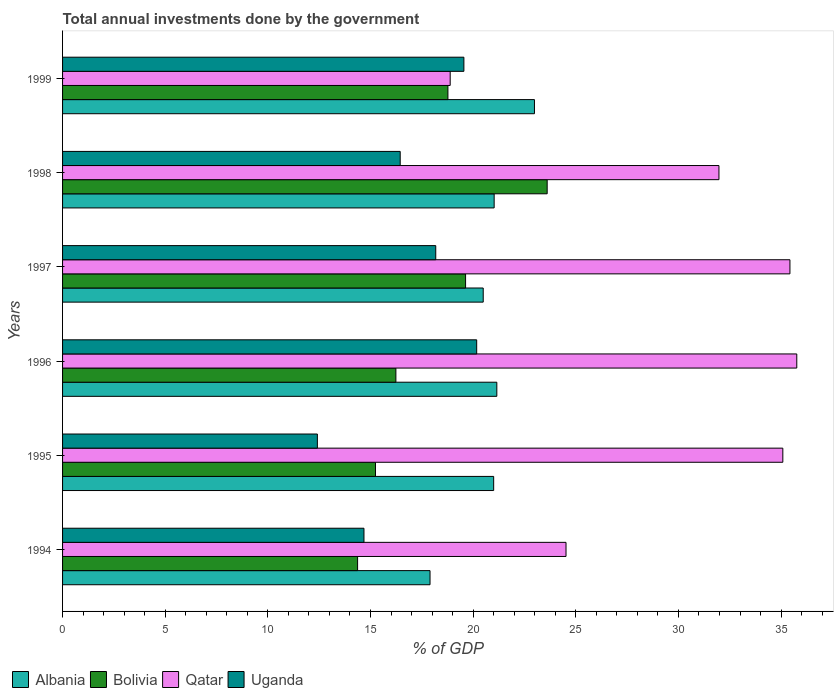How many groups of bars are there?
Offer a terse response. 6. How many bars are there on the 1st tick from the top?
Provide a short and direct response. 4. How many bars are there on the 3rd tick from the bottom?
Offer a terse response. 4. What is the total annual investments done by the government in Qatar in 1999?
Your answer should be compact. 18.88. Across all years, what is the maximum total annual investments done by the government in Bolivia?
Provide a succinct answer. 23.61. Across all years, what is the minimum total annual investments done by the government in Qatar?
Your answer should be compact. 18.88. In which year was the total annual investments done by the government in Albania minimum?
Your response must be concise. 1994. What is the total total annual investments done by the government in Albania in the graph?
Provide a short and direct response. 124.56. What is the difference between the total annual investments done by the government in Bolivia in 1997 and that in 1999?
Offer a terse response. 0.86. What is the difference between the total annual investments done by the government in Albania in 1994 and the total annual investments done by the government in Bolivia in 1996?
Offer a very short reply. 1.66. What is the average total annual investments done by the government in Qatar per year?
Provide a succinct answer. 30.28. In the year 1995, what is the difference between the total annual investments done by the government in Bolivia and total annual investments done by the government in Uganda?
Ensure brevity in your answer.  2.83. What is the ratio of the total annual investments done by the government in Bolivia in 1994 to that in 1995?
Your response must be concise. 0.94. Is the difference between the total annual investments done by the government in Bolivia in 1994 and 1998 greater than the difference between the total annual investments done by the government in Uganda in 1994 and 1998?
Offer a very short reply. No. What is the difference between the highest and the second highest total annual investments done by the government in Bolivia?
Give a very brief answer. 3.97. What is the difference between the highest and the lowest total annual investments done by the government in Bolivia?
Ensure brevity in your answer.  9.24. Is the sum of the total annual investments done by the government in Qatar in 1995 and 1997 greater than the maximum total annual investments done by the government in Albania across all years?
Provide a succinct answer. Yes. What does the 2nd bar from the top in 1998 represents?
Your response must be concise. Qatar. What does the 3rd bar from the bottom in 1998 represents?
Offer a terse response. Qatar. How many bars are there?
Provide a succinct answer. 24. What is the difference between two consecutive major ticks on the X-axis?
Offer a terse response. 5. Does the graph contain any zero values?
Keep it short and to the point. No. Does the graph contain grids?
Make the answer very short. No. How are the legend labels stacked?
Keep it short and to the point. Horizontal. What is the title of the graph?
Ensure brevity in your answer.  Total annual investments done by the government. Does "Madagascar" appear as one of the legend labels in the graph?
Offer a terse response. No. What is the label or title of the X-axis?
Give a very brief answer. % of GDP. What is the % of GDP in Albania in 1994?
Ensure brevity in your answer.  17.9. What is the % of GDP in Bolivia in 1994?
Offer a terse response. 14.37. What is the % of GDP in Qatar in 1994?
Offer a very short reply. 24.52. What is the % of GDP of Uganda in 1994?
Provide a short and direct response. 14.68. What is the % of GDP in Albania in 1995?
Offer a very short reply. 21. What is the % of GDP in Bolivia in 1995?
Make the answer very short. 15.24. What is the % of GDP of Qatar in 1995?
Your response must be concise. 35.09. What is the % of GDP of Uganda in 1995?
Offer a very short reply. 12.41. What is the % of GDP of Albania in 1996?
Offer a very short reply. 21.15. What is the % of GDP in Bolivia in 1996?
Provide a succinct answer. 16.24. What is the % of GDP of Qatar in 1996?
Provide a succinct answer. 35.77. What is the % of GDP in Uganda in 1996?
Keep it short and to the point. 20.17. What is the % of GDP in Albania in 1997?
Keep it short and to the point. 20.49. What is the % of GDP in Bolivia in 1997?
Offer a very short reply. 19.63. What is the % of GDP of Qatar in 1997?
Your answer should be very brief. 35.43. What is the % of GDP in Uganda in 1997?
Keep it short and to the point. 18.18. What is the % of GDP in Albania in 1998?
Your answer should be very brief. 21.02. What is the % of GDP of Bolivia in 1998?
Your answer should be very brief. 23.61. What is the % of GDP of Qatar in 1998?
Your answer should be compact. 31.97. What is the % of GDP in Uganda in 1998?
Keep it short and to the point. 16.45. What is the % of GDP in Albania in 1999?
Offer a terse response. 22.99. What is the % of GDP of Bolivia in 1999?
Keep it short and to the point. 18.77. What is the % of GDP in Qatar in 1999?
Your response must be concise. 18.88. What is the % of GDP in Uganda in 1999?
Ensure brevity in your answer.  19.55. Across all years, what is the maximum % of GDP in Albania?
Ensure brevity in your answer.  22.99. Across all years, what is the maximum % of GDP of Bolivia?
Make the answer very short. 23.61. Across all years, what is the maximum % of GDP in Qatar?
Give a very brief answer. 35.77. Across all years, what is the maximum % of GDP of Uganda?
Make the answer very short. 20.17. Across all years, what is the minimum % of GDP of Albania?
Give a very brief answer. 17.9. Across all years, what is the minimum % of GDP of Bolivia?
Ensure brevity in your answer.  14.37. Across all years, what is the minimum % of GDP of Qatar?
Provide a short and direct response. 18.88. Across all years, what is the minimum % of GDP in Uganda?
Make the answer very short. 12.41. What is the total % of GDP of Albania in the graph?
Keep it short and to the point. 124.56. What is the total % of GDP in Bolivia in the graph?
Offer a very short reply. 107.86. What is the total % of GDP of Qatar in the graph?
Keep it short and to the point. 181.66. What is the total % of GDP in Uganda in the graph?
Provide a short and direct response. 101.44. What is the difference between the % of GDP of Albania in 1994 and that in 1995?
Give a very brief answer. -3.1. What is the difference between the % of GDP in Bolivia in 1994 and that in 1995?
Your answer should be very brief. -0.87. What is the difference between the % of GDP of Qatar in 1994 and that in 1995?
Your answer should be compact. -10.56. What is the difference between the % of GDP in Uganda in 1994 and that in 1995?
Provide a succinct answer. 2.27. What is the difference between the % of GDP in Albania in 1994 and that in 1996?
Offer a terse response. -3.25. What is the difference between the % of GDP in Bolivia in 1994 and that in 1996?
Give a very brief answer. -1.87. What is the difference between the % of GDP in Qatar in 1994 and that in 1996?
Provide a short and direct response. -11.24. What is the difference between the % of GDP of Uganda in 1994 and that in 1996?
Offer a terse response. -5.49. What is the difference between the % of GDP in Albania in 1994 and that in 1997?
Offer a very short reply. -2.59. What is the difference between the % of GDP in Bolivia in 1994 and that in 1997?
Offer a very short reply. -5.26. What is the difference between the % of GDP in Qatar in 1994 and that in 1997?
Offer a very short reply. -10.91. What is the difference between the % of GDP in Uganda in 1994 and that in 1997?
Give a very brief answer. -3.5. What is the difference between the % of GDP in Albania in 1994 and that in 1998?
Offer a terse response. -3.12. What is the difference between the % of GDP of Bolivia in 1994 and that in 1998?
Give a very brief answer. -9.24. What is the difference between the % of GDP of Qatar in 1994 and that in 1998?
Make the answer very short. -7.45. What is the difference between the % of GDP in Uganda in 1994 and that in 1998?
Offer a very short reply. -1.77. What is the difference between the % of GDP of Albania in 1994 and that in 1999?
Keep it short and to the point. -5.09. What is the difference between the % of GDP in Bolivia in 1994 and that in 1999?
Your response must be concise. -4.4. What is the difference between the % of GDP in Qatar in 1994 and that in 1999?
Ensure brevity in your answer.  5.64. What is the difference between the % of GDP of Uganda in 1994 and that in 1999?
Keep it short and to the point. -4.87. What is the difference between the % of GDP in Albania in 1995 and that in 1996?
Give a very brief answer. -0.15. What is the difference between the % of GDP in Bolivia in 1995 and that in 1996?
Your response must be concise. -0.99. What is the difference between the % of GDP in Qatar in 1995 and that in 1996?
Your response must be concise. -0.68. What is the difference between the % of GDP in Uganda in 1995 and that in 1996?
Your response must be concise. -7.76. What is the difference between the % of GDP in Albania in 1995 and that in 1997?
Ensure brevity in your answer.  0.51. What is the difference between the % of GDP of Bolivia in 1995 and that in 1997?
Your response must be concise. -4.39. What is the difference between the % of GDP of Qatar in 1995 and that in 1997?
Your answer should be very brief. -0.35. What is the difference between the % of GDP in Uganda in 1995 and that in 1997?
Provide a succinct answer. -5.77. What is the difference between the % of GDP of Albania in 1995 and that in 1998?
Ensure brevity in your answer.  -0.02. What is the difference between the % of GDP of Bolivia in 1995 and that in 1998?
Make the answer very short. -8.36. What is the difference between the % of GDP in Qatar in 1995 and that in 1998?
Offer a very short reply. 3.11. What is the difference between the % of GDP in Uganda in 1995 and that in 1998?
Provide a short and direct response. -4.04. What is the difference between the % of GDP of Albania in 1995 and that in 1999?
Give a very brief answer. -1.99. What is the difference between the % of GDP of Bolivia in 1995 and that in 1999?
Your answer should be very brief. -3.53. What is the difference between the % of GDP in Qatar in 1995 and that in 1999?
Make the answer very short. 16.2. What is the difference between the % of GDP in Uganda in 1995 and that in 1999?
Provide a succinct answer. -7.14. What is the difference between the % of GDP in Albania in 1996 and that in 1997?
Your answer should be compact. 0.66. What is the difference between the % of GDP in Bolivia in 1996 and that in 1997?
Give a very brief answer. -3.39. What is the difference between the % of GDP in Qatar in 1996 and that in 1997?
Provide a short and direct response. 0.33. What is the difference between the % of GDP of Uganda in 1996 and that in 1997?
Provide a succinct answer. 1.99. What is the difference between the % of GDP in Albania in 1996 and that in 1998?
Your answer should be very brief. 0.13. What is the difference between the % of GDP of Bolivia in 1996 and that in 1998?
Ensure brevity in your answer.  -7.37. What is the difference between the % of GDP of Qatar in 1996 and that in 1998?
Offer a very short reply. 3.79. What is the difference between the % of GDP of Uganda in 1996 and that in 1998?
Provide a succinct answer. 3.73. What is the difference between the % of GDP of Albania in 1996 and that in 1999?
Offer a very short reply. -1.83. What is the difference between the % of GDP of Bolivia in 1996 and that in 1999?
Make the answer very short. -2.53. What is the difference between the % of GDP in Qatar in 1996 and that in 1999?
Provide a succinct answer. 16.88. What is the difference between the % of GDP of Uganda in 1996 and that in 1999?
Offer a very short reply. 0.62. What is the difference between the % of GDP of Albania in 1997 and that in 1998?
Make the answer very short. -0.53. What is the difference between the % of GDP in Bolivia in 1997 and that in 1998?
Keep it short and to the point. -3.97. What is the difference between the % of GDP in Qatar in 1997 and that in 1998?
Make the answer very short. 3.46. What is the difference between the % of GDP in Uganda in 1997 and that in 1998?
Your answer should be compact. 1.73. What is the difference between the % of GDP of Albania in 1997 and that in 1999?
Give a very brief answer. -2.5. What is the difference between the % of GDP in Bolivia in 1997 and that in 1999?
Provide a succinct answer. 0.86. What is the difference between the % of GDP in Qatar in 1997 and that in 1999?
Your answer should be very brief. 16.55. What is the difference between the % of GDP of Uganda in 1997 and that in 1999?
Provide a succinct answer. -1.37. What is the difference between the % of GDP in Albania in 1998 and that in 1999?
Offer a terse response. -1.96. What is the difference between the % of GDP in Bolivia in 1998 and that in 1999?
Offer a very short reply. 4.83. What is the difference between the % of GDP in Qatar in 1998 and that in 1999?
Keep it short and to the point. 13.09. What is the difference between the % of GDP in Uganda in 1998 and that in 1999?
Offer a terse response. -3.1. What is the difference between the % of GDP in Albania in 1994 and the % of GDP in Bolivia in 1995?
Provide a succinct answer. 2.66. What is the difference between the % of GDP of Albania in 1994 and the % of GDP of Qatar in 1995?
Your answer should be very brief. -17.19. What is the difference between the % of GDP in Albania in 1994 and the % of GDP in Uganda in 1995?
Keep it short and to the point. 5.49. What is the difference between the % of GDP of Bolivia in 1994 and the % of GDP of Qatar in 1995?
Ensure brevity in your answer.  -20.71. What is the difference between the % of GDP in Bolivia in 1994 and the % of GDP in Uganda in 1995?
Provide a succinct answer. 1.96. What is the difference between the % of GDP in Qatar in 1994 and the % of GDP in Uganda in 1995?
Your response must be concise. 12.11. What is the difference between the % of GDP of Albania in 1994 and the % of GDP of Bolivia in 1996?
Ensure brevity in your answer.  1.66. What is the difference between the % of GDP of Albania in 1994 and the % of GDP of Qatar in 1996?
Offer a terse response. -17.87. What is the difference between the % of GDP of Albania in 1994 and the % of GDP of Uganda in 1996?
Offer a very short reply. -2.27. What is the difference between the % of GDP in Bolivia in 1994 and the % of GDP in Qatar in 1996?
Ensure brevity in your answer.  -21.39. What is the difference between the % of GDP in Bolivia in 1994 and the % of GDP in Uganda in 1996?
Ensure brevity in your answer.  -5.8. What is the difference between the % of GDP in Qatar in 1994 and the % of GDP in Uganda in 1996?
Your answer should be very brief. 4.35. What is the difference between the % of GDP of Albania in 1994 and the % of GDP of Bolivia in 1997?
Provide a succinct answer. -1.73. What is the difference between the % of GDP of Albania in 1994 and the % of GDP of Qatar in 1997?
Ensure brevity in your answer.  -17.53. What is the difference between the % of GDP of Albania in 1994 and the % of GDP of Uganda in 1997?
Offer a very short reply. -0.28. What is the difference between the % of GDP in Bolivia in 1994 and the % of GDP in Qatar in 1997?
Ensure brevity in your answer.  -21.06. What is the difference between the % of GDP of Bolivia in 1994 and the % of GDP of Uganda in 1997?
Offer a very short reply. -3.81. What is the difference between the % of GDP of Qatar in 1994 and the % of GDP of Uganda in 1997?
Ensure brevity in your answer.  6.35. What is the difference between the % of GDP of Albania in 1994 and the % of GDP of Bolivia in 1998?
Ensure brevity in your answer.  -5.71. What is the difference between the % of GDP of Albania in 1994 and the % of GDP of Qatar in 1998?
Keep it short and to the point. -14.07. What is the difference between the % of GDP in Albania in 1994 and the % of GDP in Uganda in 1998?
Your response must be concise. 1.45. What is the difference between the % of GDP in Bolivia in 1994 and the % of GDP in Qatar in 1998?
Give a very brief answer. -17.6. What is the difference between the % of GDP in Bolivia in 1994 and the % of GDP in Uganda in 1998?
Offer a very short reply. -2.08. What is the difference between the % of GDP of Qatar in 1994 and the % of GDP of Uganda in 1998?
Keep it short and to the point. 8.08. What is the difference between the % of GDP of Albania in 1994 and the % of GDP of Bolivia in 1999?
Offer a very short reply. -0.87. What is the difference between the % of GDP in Albania in 1994 and the % of GDP in Qatar in 1999?
Make the answer very short. -0.98. What is the difference between the % of GDP in Albania in 1994 and the % of GDP in Uganda in 1999?
Your answer should be very brief. -1.65. What is the difference between the % of GDP of Bolivia in 1994 and the % of GDP of Qatar in 1999?
Offer a terse response. -4.51. What is the difference between the % of GDP of Bolivia in 1994 and the % of GDP of Uganda in 1999?
Your answer should be very brief. -5.18. What is the difference between the % of GDP in Qatar in 1994 and the % of GDP in Uganda in 1999?
Your response must be concise. 4.97. What is the difference between the % of GDP of Albania in 1995 and the % of GDP of Bolivia in 1996?
Your answer should be compact. 4.76. What is the difference between the % of GDP in Albania in 1995 and the % of GDP in Qatar in 1996?
Keep it short and to the point. -14.77. What is the difference between the % of GDP in Albania in 1995 and the % of GDP in Uganda in 1996?
Keep it short and to the point. 0.83. What is the difference between the % of GDP of Bolivia in 1995 and the % of GDP of Qatar in 1996?
Your answer should be compact. -20.52. What is the difference between the % of GDP in Bolivia in 1995 and the % of GDP in Uganda in 1996?
Ensure brevity in your answer.  -4.93. What is the difference between the % of GDP in Qatar in 1995 and the % of GDP in Uganda in 1996?
Your answer should be compact. 14.91. What is the difference between the % of GDP of Albania in 1995 and the % of GDP of Bolivia in 1997?
Make the answer very short. 1.37. What is the difference between the % of GDP of Albania in 1995 and the % of GDP of Qatar in 1997?
Make the answer very short. -14.43. What is the difference between the % of GDP in Albania in 1995 and the % of GDP in Uganda in 1997?
Offer a terse response. 2.82. What is the difference between the % of GDP of Bolivia in 1995 and the % of GDP of Qatar in 1997?
Give a very brief answer. -20.19. What is the difference between the % of GDP in Bolivia in 1995 and the % of GDP in Uganda in 1997?
Make the answer very short. -2.93. What is the difference between the % of GDP of Qatar in 1995 and the % of GDP of Uganda in 1997?
Make the answer very short. 16.91. What is the difference between the % of GDP in Albania in 1995 and the % of GDP in Bolivia in 1998?
Offer a very short reply. -2.61. What is the difference between the % of GDP in Albania in 1995 and the % of GDP in Qatar in 1998?
Provide a short and direct response. -10.97. What is the difference between the % of GDP of Albania in 1995 and the % of GDP of Uganda in 1998?
Provide a succinct answer. 4.55. What is the difference between the % of GDP of Bolivia in 1995 and the % of GDP of Qatar in 1998?
Your response must be concise. -16.73. What is the difference between the % of GDP of Bolivia in 1995 and the % of GDP of Uganda in 1998?
Give a very brief answer. -1.2. What is the difference between the % of GDP of Qatar in 1995 and the % of GDP of Uganda in 1998?
Your response must be concise. 18.64. What is the difference between the % of GDP of Albania in 1995 and the % of GDP of Bolivia in 1999?
Provide a short and direct response. 2.23. What is the difference between the % of GDP of Albania in 1995 and the % of GDP of Qatar in 1999?
Your answer should be very brief. 2.12. What is the difference between the % of GDP in Albania in 1995 and the % of GDP in Uganda in 1999?
Your response must be concise. 1.45. What is the difference between the % of GDP of Bolivia in 1995 and the % of GDP of Qatar in 1999?
Make the answer very short. -3.64. What is the difference between the % of GDP in Bolivia in 1995 and the % of GDP in Uganda in 1999?
Offer a terse response. -4.31. What is the difference between the % of GDP in Qatar in 1995 and the % of GDP in Uganda in 1999?
Make the answer very short. 15.54. What is the difference between the % of GDP in Albania in 1996 and the % of GDP in Bolivia in 1997?
Keep it short and to the point. 1.52. What is the difference between the % of GDP of Albania in 1996 and the % of GDP of Qatar in 1997?
Your response must be concise. -14.28. What is the difference between the % of GDP of Albania in 1996 and the % of GDP of Uganda in 1997?
Keep it short and to the point. 2.98. What is the difference between the % of GDP of Bolivia in 1996 and the % of GDP of Qatar in 1997?
Ensure brevity in your answer.  -19.19. What is the difference between the % of GDP in Bolivia in 1996 and the % of GDP in Uganda in 1997?
Your response must be concise. -1.94. What is the difference between the % of GDP of Qatar in 1996 and the % of GDP of Uganda in 1997?
Keep it short and to the point. 17.59. What is the difference between the % of GDP in Albania in 1996 and the % of GDP in Bolivia in 1998?
Your response must be concise. -2.45. What is the difference between the % of GDP in Albania in 1996 and the % of GDP in Qatar in 1998?
Make the answer very short. -10.82. What is the difference between the % of GDP in Albania in 1996 and the % of GDP in Uganda in 1998?
Offer a terse response. 4.71. What is the difference between the % of GDP of Bolivia in 1996 and the % of GDP of Qatar in 1998?
Give a very brief answer. -15.74. What is the difference between the % of GDP of Bolivia in 1996 and the % of GDP of Uganda in 1998?
Your response must be concise. -0.21. What is the difference between the % of GDP in Qatar in 1996 and the % of GDP in Uganda in 1998?
Your answer should be very brief. 19.32. What is the difference between the % of GDP in Albania in 1996 and the % of GDP in Bolivia in 1999?
Provide a short and direct response. 2.38. What is the difference between the % of GDP of Albania in 1996 and the % of GDP of Qatar in 1999?
Your response must be concise. 2.27. What is the difference between the % of GDP of Albania in 1996 and the % of GDP of Uganda in 1999?
Your response must be concise. 1.61. What is the difference between the % of GDP in Bolivia in 1996 and the % of GDP in Qatar in 1999?
Offer a very short reply. -2.65. What is the difference between the % of GDP of Bolivia in 1996 and the % of GDP of Uganda in 1999?
Your answer should be very brief. -3.31. What is the difference between the % of GDP in Qatar in 1996 and the % of GDP in Uganda in 1999?
Make the answer very short. 16.22. What is the difference between the % of GDP of Albania in 1997 and the % of GDP of Bolivia in 1998?
Provide a succinct answer. -3.12. What is the difference between the % of GDP in Albania in 1997 and the % of GDP in Qatar in 1998?
Offer a very short reply. -11.48. What is the difference between the % of GDP of Albania in 1997 and the % of GDP of Uganda in 1998?
Give a very brief answer. 4.04. What is the difference between the % of GDP of Bolivia in 1997 and the % of GDP of Qatar in 1998?
Provide a succinct answer. -12.34. What is the difference between the % of GDP in Bolivia in 1997 and the % of GDP in Uganda in 1998?
Give a very brief answer. 3.18. What is the difference between the % of GDP of Qatar in 1997 and the % of GDP of Uganda in 1998?
Give a very brief answer. 18.98. What is the difference between the % of GDP of Albania in 1997 and the % of GDP of Bolivia in 1999?
Your response must be concise. 1.72. What is the difference between the % of GDP of Albania in 1997 and the % of GDP of Qatar in 1999?
Your response must be concise. 1.61. What is the difference between the % of GDP of Albania in 1997 and the % of GDP of Uganda in 1999?
Your answer should be compact. 0.94. What is the difference between the % of GDP in Bolivia in 1997 and the % of GDP in Qatar in 1999?
Make the answer very short. 0.75. What is the difference between the % of GDP of Bolivia in 1997 and the % of GDP of Uganda in 1999?
Offer a terse response. 0.08. What is the difference between the % of GDP of Qatar in 1997 and the % of GDP of Uganda in 1999?
Offer a very short reply. 15.88. What is the difference between the % of GDP of Albania in 1998 and the % of GDP of Bolivia in 1999?
Provide a succinct answer. 2.25. What is the difference between the % of GDP of Albania in 1998 and the % of GDP of Qatar in 1999?
Give a very brief answer. 2.14. What is the difference between the % of GDP in Albania in 1998 and the % of GDP in Uganda in 1999?
Your answer should be very brief. 1.47. What is the difference between the % of GDP of Bolivia in 1998 and the % of GDP of Qatar in 1999?
Give a very brief answer. 4.72. What is the difference between the % of GDP of Bolivia in 1998 and the % of GDP of Uganda in 1999?
Provide a succinct answer. 4.06. What is the difference between the % of GDP of Qatar in 1998 and the % of GDP of Uganda in 1999?
Your answer should be compact. 12.43. What is the average % of GDP of Albania per year?
Offer a very short reply. 20.76. What is the average % of GDP of Bolivia per year?
Provide a short and direct response. 17.98. What is the average % of GDP of Qatar per year?
Ensure brevity in your answer.  30.28. What is the average % of GDP of Uganda per year?
Offer a terse response. 16.91. In the year 1994, what is the difference between the % of GDP of Albania and % of GDP of Bolivia?
Your answer should be compact. 3.53. In the year 1994, what is the difference between the % of GDP in Albania and % of GDP in Qatar?
Ensure brevity in your answer.  -6.62. In the year 1994, what is the difference between the % of GDP in Albania and % of GDP in Uganda?
Keep it short and to the point. 3.22. In the year 1994, what is the difference between the % of GDP in Bolivia and % of GDP in Qatar?
Provide a short and direct response. -10.15. In the year 1994, what is the difference between the % of GDP of Bolivia and % of GDP of Uganda?
Give a very brief answer. -0.31. In the year 1994, what is the difference between the % of GDP in Qatar and % of GDP in Uganda?
Your answer should be very brief. 9.84. In the year 1995, what is the difference between the % of GDP in Albania and % of GDP in Bolivia?
Give a very brief answer. 5.76. In the year 1995, what is the difference between the % of GDP of Albania and % of GDP of Qatar?
Your answer should be very brief. -14.09. In the year 1995, what is the difference between the % of GDP in Albania and % of GDP in Uganda?
Provide a short and direct response. 8.59. In the year 1995, what is the difference between the % of GDP of Bolivia and % of GDP of Qatar?
Provide a short and direct response. -19.84. In the year 1995, what is the difference between the % of GDP of Bolivia and % of GDP of Uganda?
Make the answer very short. 2.83. In the year 1995, what is the difference between the % of GDP in Qatar and % of GDP in Uganda?
Offer a terse response. 22.67. In the year 1996, what is the difference between the % of GDP of Albania and % of GDP of Bolivia?
Provide a succinct answer. 4.92. In the year 1996, what is the difference between the % of GDP of Albania and % of GDP of Qatar?
Give a very brief answer. -14.61. In the year 1996, what is the difference between the % of GDP in Albania and % of GDP in Uganda?
Your answer should be compact. 0.98. In the year 1996, what is the difference between the % of GDP in Bolivia and % of GDP in Qatar?
Ensure brevity in your answer.  -19.53. In the year 1996, what is the difference between the % of GDP of Bolivia and % of GDP of Uganda?
Your answer should be compact. -3.94. In the year 1996, what is the difference between the % of GDP in Qatar and % of GDP in Uganda?
Keep it short and to the point. 15.59. In the year 1997, what is the difference between the % of GDP in Albania and % of GDP in Bolivia?
Give a very brief answer. 0.86. In the year 1997, what is the difference between the % of GDP of Albania and % of GDP of Qatar?
Provide a short and direct response. -14.94. In the year 1997, what is the difference between the % of GDP of Albania and % of GDP of Uganda?
Ensure brevity in your answer.  2.31. In the year 1997, what is the difference between the % of GDP of Bolivia and % of GDP of Qatar?
Your response must be concise. -15.8. In the year 1997, what is the difference between the % of GDP of Bolivia and % of GDP of Uganda?
Offer a terse response. 1.45. In the year 1997, what is the difference between the % of GDP of Qatar and % of GDP of Uganda?
Provide a short and direct response. 17.25. In the year 1998, what is the difference between the % of GDP in Albania and % of GDP in Bolivia?
Keep it short and to the point. -2.58. In the year 1998, what is the difference between the % of GDP in Albania and % of GDP in Qatar?
Keep it short and to the point. -10.95. In the year 1998, what is the difference between the % of GDP in Albania and % of GDP in Uganda?
Ensure brevity in your answer.  4.58. In the year 1998, what is the difference between the % of GDP in Bolivia and % of GDP in Qatar?
Make the answer very short. -8.37. In the year 1998, what is the difference between the % of GDP in Bolivia and % of GDP in Uganda?
Your answer should be very brief. 7.16. In the year 1998, what is the difference between the % of GDP in Qatar and % of GDP in Uganda?
Your answer should be compact. 15.53. In the year 1999, what is the difference between the % of GDP of Albania and % of GDP of Bolivia?
Give a very brief answer. 4.21. In the year 1999, what is the difference between the % of GDP in Albania and % of GDP in Qatar?
Offer a terse response. 4.1. In the year 1999, what is the difference between the % of GDP in Albania and % of GDP in Uganda?
Provide a short and direct response. 3.44. In the year 1999, what is the difference between the % of GDP in Bolivia and % of GDP in Qatar?
Your answer should be very brief. -0.11. In the year 1999, what is the difference between the % of GDP of Bolivia and % of GDP of Uganda?
Offer a very short reply. -0.78. In the year 1999, what is the difference between the % of GDP in Qatar and % of GDP in Uganda?
Provide a succinct answer. -0.67. What is the ratio of the % of GDP of Albania in 1994 to that in 1995?
Make the answer very short. 0.85. What is the ratio of the % of GDP of Bolivia in 1994 to that in 1995?
Make the answer very short. 0.94. What is the ratio of the % of GDP in Qatar in 1994 to that in 1995?
Make the answer very short. 0.7. What is the ratio of the % of GDP of Uganda in 1994 to that in 1995?
Offer a terse response. 1.18. What is the ratio of the % of GDP in Albania in 1994 to that in 1996?
Keep it short and to the point. 0.85. What is the ratio of the % of GDP in Bolivia in 1994 to that in 1996?
Your answer should be compact. 0.89. What is the ratio of the % of GDP in Qatar in 1994 to that in 1996?
Make the answer very short. 0.69. What is the ratio of the % of GDP of Uganda in 1994 to that in 1996?
Your answer should be compact. 0.73. What is the ratio of the % of GDP of Albania in 1994 to that in 1997?
Offer a very short reply. 0.87. What is the ratio of the % of GDP in Bolivia in 1994 to that in 1997?
Your answer should be very brief. 0.73. What is the ratio of the % of GDP of Qatar in 1994 to that in 1997?
Keep it short and to the point. 0.69. What is the ratio of the % of GDP of Uganda in 1994 to that in 1997?
Offer a terse response. 0.81. What is the ratio of the % of GDP of Albania in 1994 to that in 1998?
Your response must be concise. 0.85. What is the ratio of the % of GDP in Bolivia in 1994 to that in 1998?
Offer a very short reply. 0.61. What is the ratio of the % of GDP in Qatar in 1994 to that in 1998?
Offer a very short reply. 0.77. What is the ratio of the % of GDP in Uganda in 1994 to that in 1998?
Your answer should be compact. 0.89. What is the ratio of the % of GDP of Albania in 1994 to that in 1999?
Provide a succinct answer. 0.78. What is the ratio of the % of GDP in Bolivia in 1994 to that in 1999?
Provide a succinct answer. 0.77. What is the ratio of the % of GDP in Qatar in 1994 to that in 1999?
Provide a succinct answer. 1.3. What is the ratio of the % of GDP of Uganda in 1994 to that in 1999?
Offer a terse response. 0.75. What is the ratio of the % of GDP of Albania in 1995 to that in 1996?
Your answer should be compact. 0.99. What is the ratio of the % of GDP of Bolivia in 1995 to that in 1996?
Keep it short and to the point. 0.94. What is the ratio of the % of GDP of Qatar in 1995 to that in 1996?
Keep it short and to the point. 0.98. What is the ratio of the % of GDP of Uganda in 1995 to that in 1996?
Keep it short and to the point. 0.62. What is the ratio of the % of GDP of Albania in 1995 to that in 1997?
Your response must be concise. 1.02. What is the ratio of the % of GDP of Bolivia in 1995 to that in 1997?
Keep it short and to the point. 0.78. What is the ratio of the % of GDP of Qatar in 1995 to that in 1997?
Your response must be concise. 0.99. What is the ratio of the % of GDP of Uganda in 1995 to that in 1997?
Give a very brief answer. 0.68. What is the ratio of the % of GDP in Albania in 1995 to that in 1998?
Your answer should be very brief. 1. What is the ratio of the % of GDP in Bolivia in 1995 to that in 1998?
Provide a succinct answer. 0.65. What is the ratio of the % of GDP in Qatar in 1995 to that in 1998?
Your answer should be compact. 1.1. What is the ratio of the % of GDP of Uganda in 1995 to that in 1998?
Your response must be concise. 0.75. What is the ratio of the % of GDP in Albania in 1995 to that in 1999?
Provide a succinct answer. 0.91. What is the ratio of the % of GDP of Bolivia in 1995 to that in 1999?
Your answer should be very brief. 0.81. What is the ratio of the % of GDP of Qatar in 1995 to that in 1999?
Your answer should be compact. 1.86. What is the ratio of the % of GDP of Uganda in 1995 to that in 1999?
Your answer should be very brief. 0.63. What is the ratio of the % of GDP in Albania in 1996 to that in 1997?
Offer a terse response. 1.03. What is the ratio of the % of GDP of Bolivia in 1996 to that in 1997?
Give a very brief answer. 0.83. What is the ratio of the % of GDP of Qatar in 1996 to that in 1997?
Offer a terse response. 1.01. What is the ratio of the % of GDP of Uganda in 1996 to that in 1997?
Your response must be concise. 1.11. What is the ratio of the % of GDP in Bolivia in 1996 to that in 1998?
Ensure brevity in your answer.  0.69. What is the ratio of the % of GDP of Qatar in 1996 to that in 1998?
Ensure brevity in your answer.  1.12. What is the ratio of the % of GDP of Uganda in 1996 to that in 1998?
Offer a very short reply. 1.23. What is the ratio of the % of GDP of Albania in 1996 to that in 1999?
Ensure brevity in your answer.  0.92. What is the ratio of the % of GDP of Bolivia in 1996 to that in 1999?
Give a very brief answer. 0.86. What is the ratio of the % of GDP in Qatar in 1996 to that in 1999?
Offer a terse response. 1.89. What is the ratio of the % of GDP of Uganda in 1996 to that in 1999?
Provide a succinct answer. 1.03. What is the ratio of the % of GDP of Albania in 1997 to that in 1998?
Your answer should be compact. 0.97. What is the ratio of the % of GDP of Bolivia in 1997 to that in 1998?
Your response must be concise. 0.83. What is the ratio of the % of GDP in Qatar in 1997 to that in 1998?
Provide a succinct answer. 1.11. What is the ratio of the % of GDP in Uganda in 1997 to that in 1998?
Provide a succinct answer. 1.11. What is the ratio of the % of GDP in Albania in 1997 to that in 1999?
Your response must be concise. 0.89. What is the ratio of the % of GDP in Bolivia in 1997 to that in 1999?
Ensure brevity in your answer.  1.05. What is the ratio of the % of GDP in Qatar in 1997 to that in 1999?
Your answer should be very brief. 1.88. What is the ratio of the % of GDP in Uganda in 1997 to that in 1999?
Your answer should be very brief. 0.93. What is the ratio of the % of GDP of Albania in 1998 to that in 1999?
Provide a short and direct response. 0.91. What is the ratio of the % of GDP in Bolivia in 1998 to that in 1999?
Provide a short and direct response. 1.26. What is the ratio of the % of GDP in Qatar in 1998 to that in 1999?
Provide a succinct answer. 1.69. What is the ratio of the % of GDP in Uganda in 1998 to that in 1999?
Provide a succinct answer. 0.84. What is the difference between the highest and the second highest % of GDP of Albania?
Provide a short and direct response. 1.83. What is the difference between the highest and the second highest % of GDP of Bolivia?
Offer a very short reply. 3.97. What is the difference between the highest and the second highest % of GDP of Qatar?
Offer a very short reply. 0.33. What is the difference between the highest and the second highest % of GDP in Uganda?
Keep it short and to the point. 0.62. What is the difference between the highest and the lowest % of GDP of Albania?
Offer a very short reply. 5.09. What is the difference between the highest and the lowest % of GDP in Bolivia?
Provide a short and direct response. 9.24. What is the difference between the highest and the lowest % of GDP of Qatar?
Make the answer very short. 16.88. What is the difference between the highest and the lowest % of GDP in Uganda?
Give a very brief answer. 7.76. 